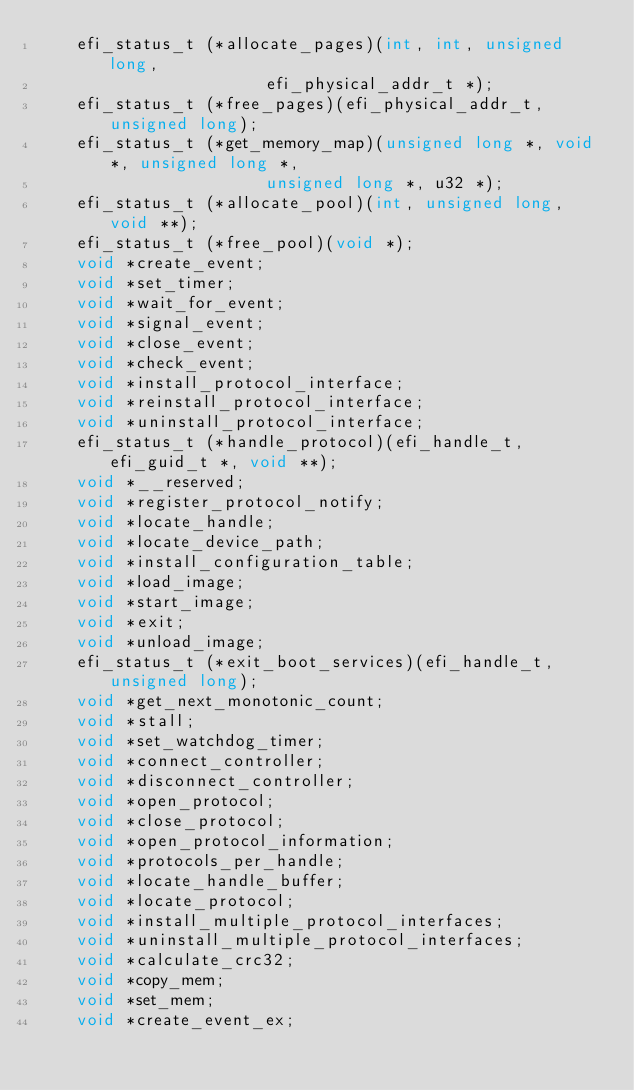Convert code to text. <code><loc_0><loc_0><loc_500><loc_500><_C_>	efi_status_t (*allocate_pages)(int, int, unsigned long,
				       efi_physical_addr_t *);
	efi_status_t (*free_pages)(efi_physical_addr_t, unsigned long);
	efi_status_t (*get_memory_map)(unsigned long *, void *, unsigned long *,
				       unsigned long *, u32 *);
	efi_status_t (*allocate_pool)(int, unsigned long, void **);
	efi_status_t (*free_pool)(void *);
	void *create_event;
	void *set_timer;
	void *wait_for_event;
	void *signal_event;
	void *close_event;
	void *check_event;
	void *install_protocol_interface;
	void *reinstall_protocol_interface;
	void *uninstall_protocol_interface;
	efi_status_t (*handle_protocol)(efi_handle_t, efi_guid_t *, void **);
	void *__reserved;
	void *register_protocol_notify;
	void *locate_handle;
	void *locate_device_path;
	void *install_configuration_table;
	void *load_image;
	void *start_image;
	void *exit;
	void *unload_image;
	efi_status_t (*exit_boot_services)(efi_handle_t, unsigned long);
	void *get_next_monotonic_count;
	void *stall;
	void *set_watchdog_timer;
	void *connect_controller;
	void *disconnect_controller;
	void *open_protocol;
	void *close_protocol;
	void *open_protocol_information;
	void *protocols_per_handle;
	void *locate_handle_buffer;
	void *locate_protocol;
	void *install_multiple_protocol_interfaces;
	void *uninstall_multiple_protocol_interfaces;
	void *calculate_crc32;
	void *copy_mem;
	void *set_mem;
	void *create_event_ex;</code> 